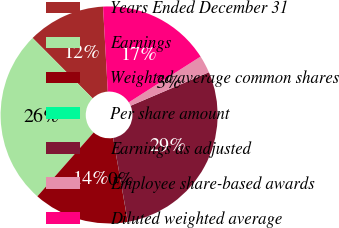Convert chart to OTSL. <chart><loc_0><loc_0><loc_500><loc_500><pie_chart><fcel>Years Ended December 31<fcel>Earnings<fcel>Weighted average common shares<fcel>Per share amount<fcel>Earnings as adjusted<fcel>Employee share-based awards<fcel>Diluted weighted average<nl><fcel>11.56%<fcel>26.05%<fcel>14.25%<fcel>0.01%<fcel>28.66%<fcel>2.61%<fcel>16.85%<nl></chart> 